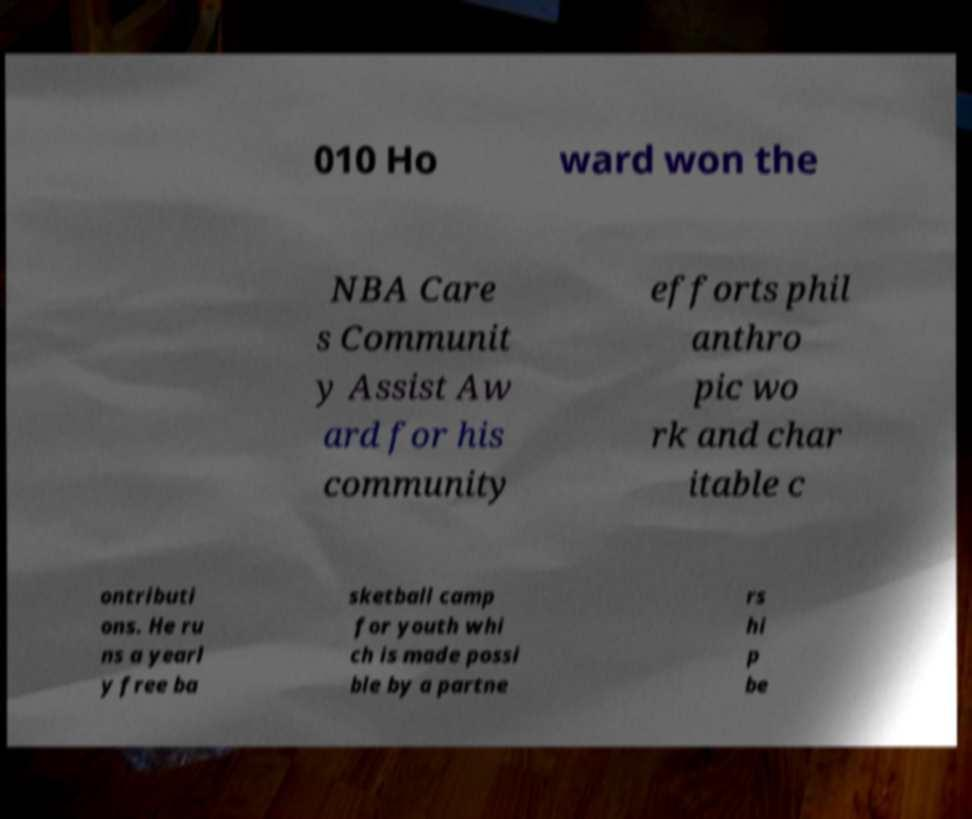What messages or text are displayed in this image? I need them in a readable, typed format. 010 Ho ward won the NBA Care s Communit y Assist Aw ard for his community efforts phil anthro pic wo rk and char itable c ontributi ons. He ru ns a yearl y free ba sketball camp for youth whi ch is made possi ble by a partne rs hi p be 